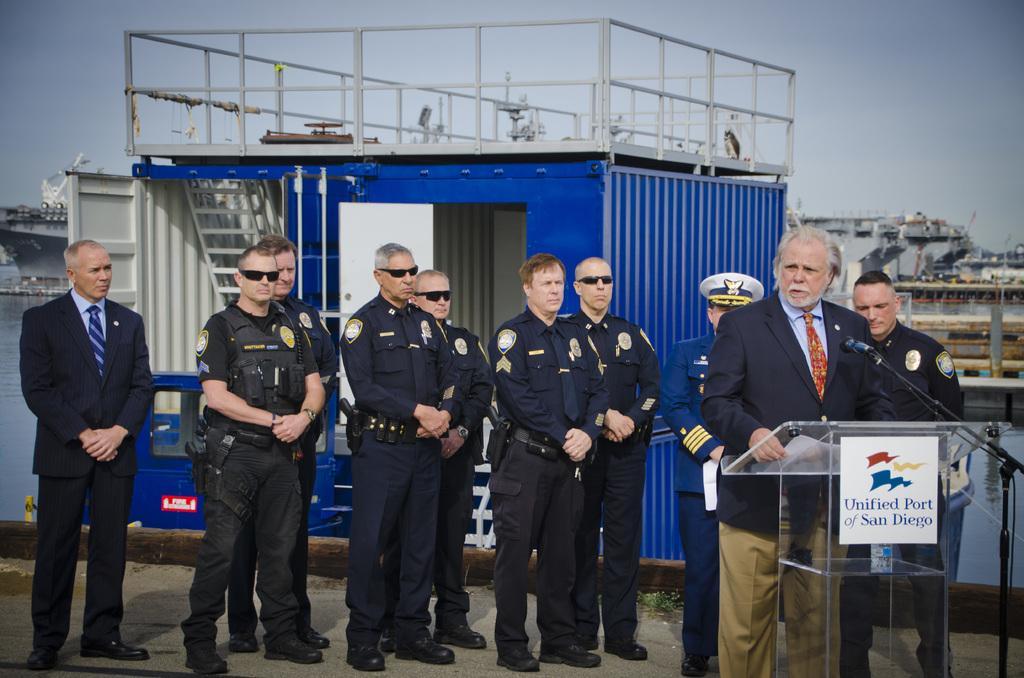Can you describe this image briefly? In this image we can see few people standing on the ground, a person is standing near the podium and holding a paper, there is a board attached to the podium and a mic beside the podium, in the background there is a blue color object looks like a container, there are few ships on the water and a bridge and the sky. 